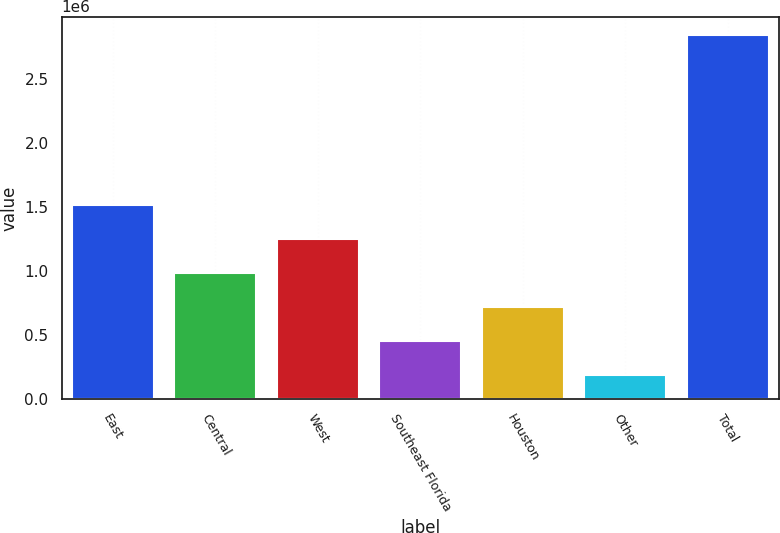Convert chart. <chart><loc_0><loc_0><loc_500><loc_500><bar_chart><fcel>East<fcel>Central<fcel>West<fcel>Southeast Florida<fcel>Houston<fcel>Other<fcel>Total<nl><fcel>1.51705e+06<fcel>986093<fcel>1.25157e+06<fcel>455136<fcel>720615<fcel>189658<fcel>2.84444e+06<nl></chart> 